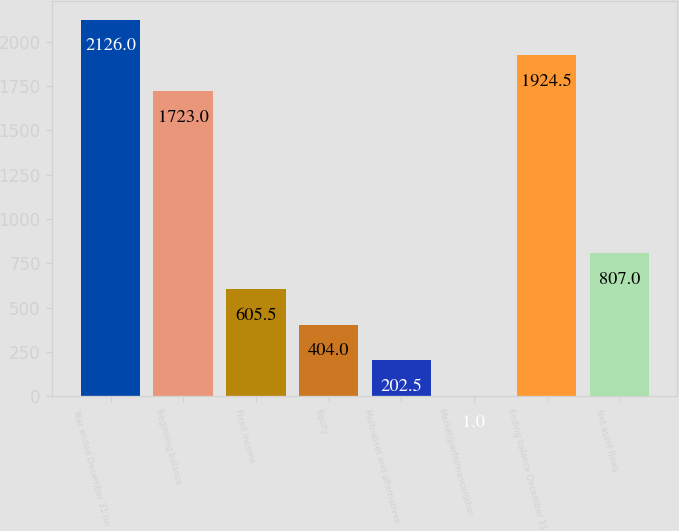Convert chart. <chart><loc_0><loc_0><loc_500><loc_500><bar_chart><fcel>Year ended December 31 (in<fcel>Beginning balance<fcel>Fixed income<fcel>Equity<fcel>Multi-asset and alternatives<fcel>Market/performance/other<fcel>Ending balance December 31<fcel>Net asset flows<nl><fcel>2126<fcel>1723<fcel>605.5<fcel>404<fcel>202.5<fcel>1<fcel>1924.5<fcel>807<nl></chart> 